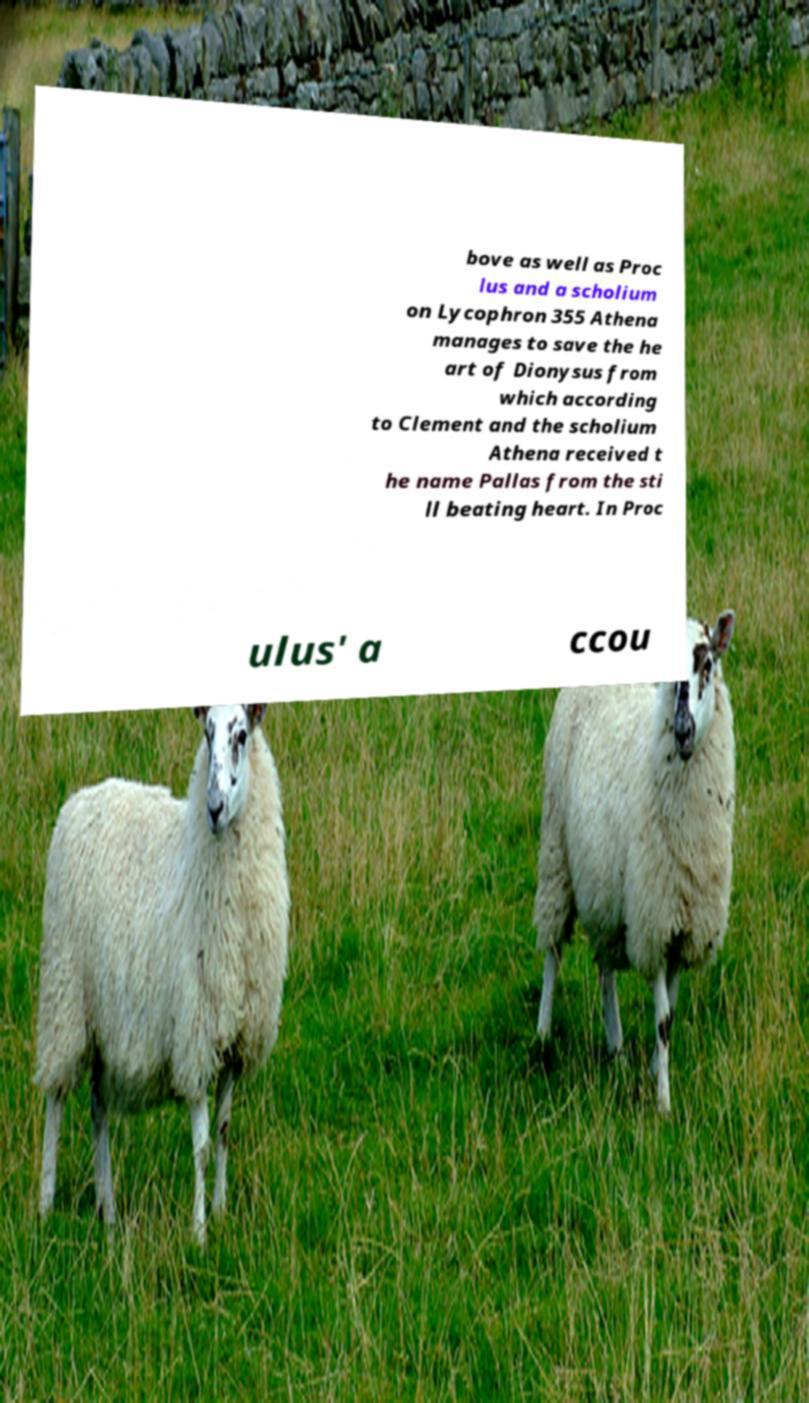Could you extract and type out the text from this image? bove as well as Proc lus and a scholium on Lycophron 355 Athena manages to save the he art of Dionysus from which according to Clement and the scholium Athena received t he name Pallas from the sti ll beating heart. In Proc ulus' a ccou 